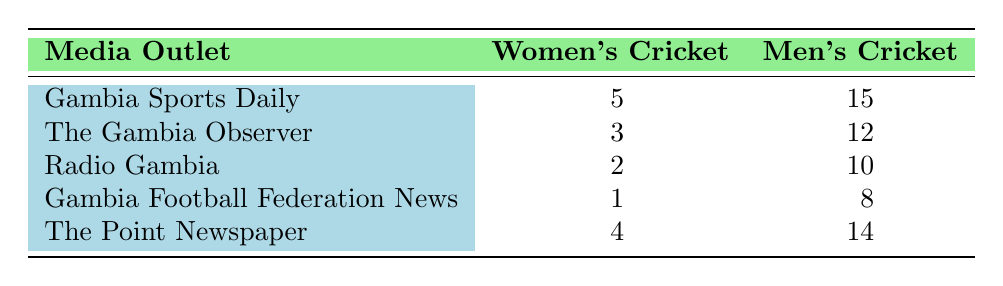What is the total number of articles per month for women's cricket across all media outlets? To find the total number of articles for women's cricket, I will sum the articles per month from each media outlet. The values are 5 (Gambia Sports Daily) + 3 (The Gambia Observer) + 2 (Radio Gambia) + 1 (Gambia Football Federation News) + 4 (The Point Newspaper) = 15.
Answer: 15 Which media outlet has the highest coverage for men's cricket? By examining the articles per month for men's cricket from each media outlet, I see that Gambia Sports Daily has 15 articles, which is higher than the others: 12 (The Gambia Observer), 10 (Radio Gambia), 8 (Gambia Football Federation News), and 14 (The Point Newspaper).
Answer: Gambia Sports Daily Is there any media outlet that provides more articles for women's cricket than men's cricket? By comparing the articles for women's and men's cricket for each media outlet, all outlets show a higher number of articles for men's cricket. This means there is no media outlet with more articles for women's cricket.
Answer: No What is the difference in articles per month between women's cricket and men's cricket for The Point Newspaper? I will calculate the difference by subtracting the number of articles for women's cricket (4) from men's cricket (14). The difference is 14 - 4 = 10.
Answer: 10 What is the average number of articles per month for women's cricket across the media outlets? To calculate the average, I first sum the number of articles for women's cricket, which is 15, and divide by the number of media outlets, which is 5. Therefore, the average is 15 / 5 = 3.
Answer: 3 Are there any media outlets that have an equal number of articles for both women's and men's cricket? Checking the articles per month, all outlets have different counts between women's and men's cricket; there are no outlets with equal articles for both.
Answer: No Which media outlet has the least coverage for women's cricket? By looking at the values for women's cricket articles per month, Gambia Football Federation News has the lowest at 1 article, compared to all other outlets that have more.
Answer: Gambia Football Federation News What is the combined total of articles per month for both sports in Radio Gambia? I will add the articles for women's cricket (2) and men's cricket (10): 2 + 10 = 12, so the combined total is 12 articles.
Answer: 12 